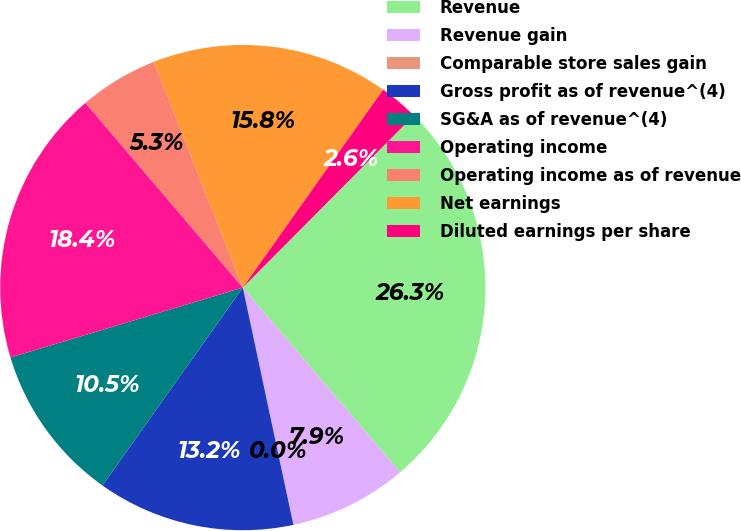Convert chart. <chart><loc_0><loc_0><loc_500><loc_500><pie_chart><fcel>Revenue<fcel>Revenue gain<fcel>Comparable store sales gain<fcel>Gross profit as of revenue^(4)<fcel>SG&A as of revenue^(4)<fcel>Operating income<fcel>Operating income as of revenue<fcel>Net earnings<fcel>Diluted earnings per share<nl><fcel>26.32%<fcel>7.89%<fcel>0.0%<fcel>13.16%<fcel>10.53%<fcel>18.42%<fcel>5.26%<fcel>15.79%<fcel>2.63%<nl></chart> 